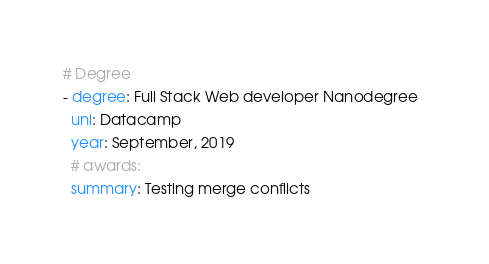<code> <loc_0><loc_0><loc_500><loc_500><_YAML_># Degree
- degree: Full Stack Web developer Nanodegree  
  uni: Datacamp
  year: September, 2019
  # awards:
  summary: Testing merge conflicts
</code> 